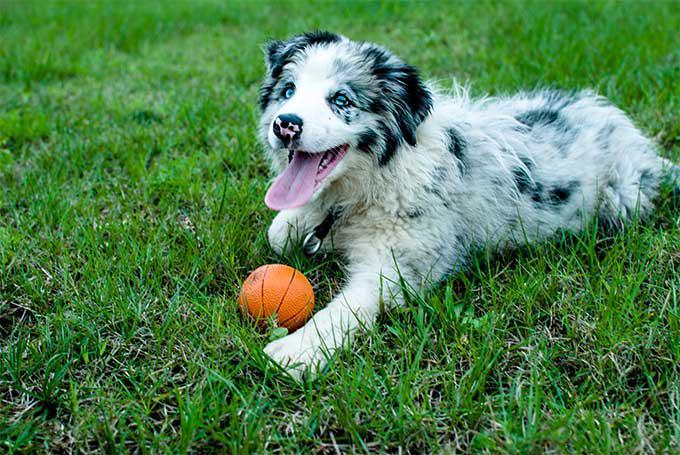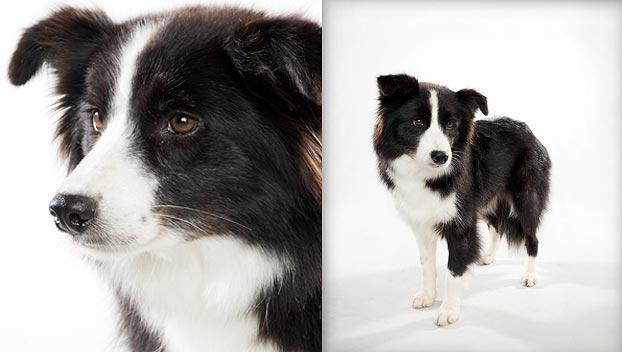The first image is the image on the left, the second image is the image on the right. For the images shown, is this caption "The left image depicts only a canine-type animal on the grass." true? Answer yes or no. Yes. 